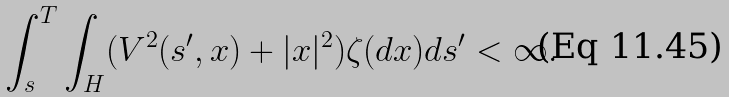Convert formula to latex. <formula><loc_0><loc_0><loc_500><loc_500>\int _ { s } ^ { T } \int _ { H } ( V ^ { 2 } ( s ^ { \prime } , x ) + | x | ^ { 2 } ) \zeta ( d x ) d s ^ { \prime } < \infty .</formula> 